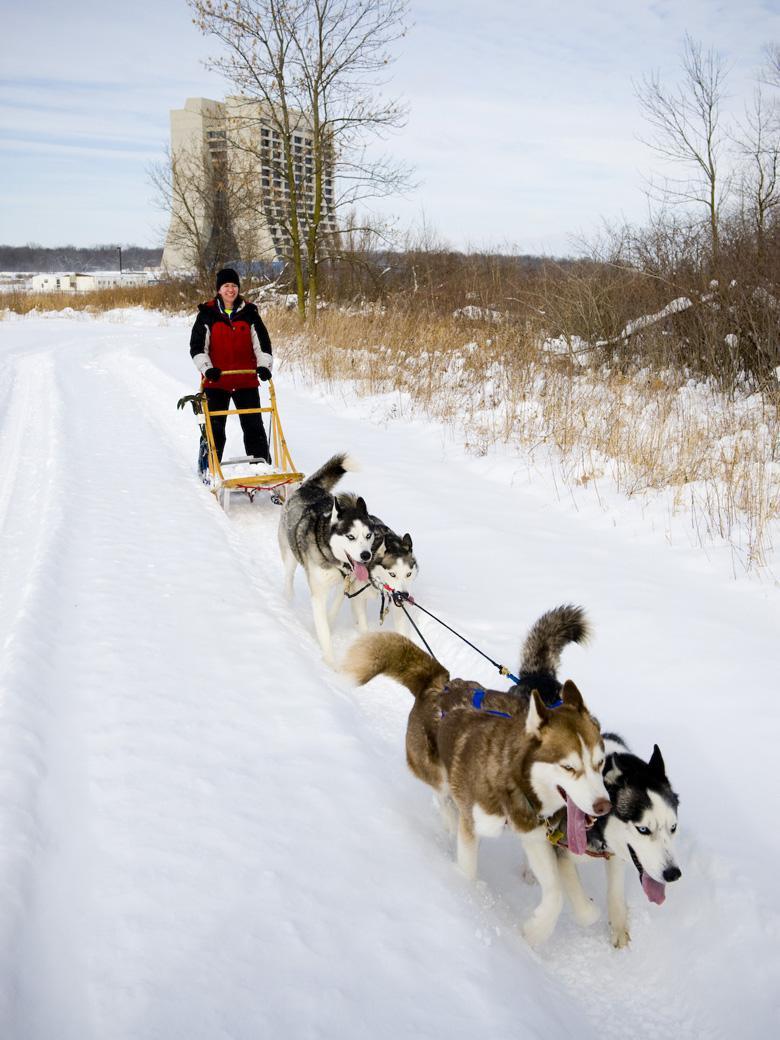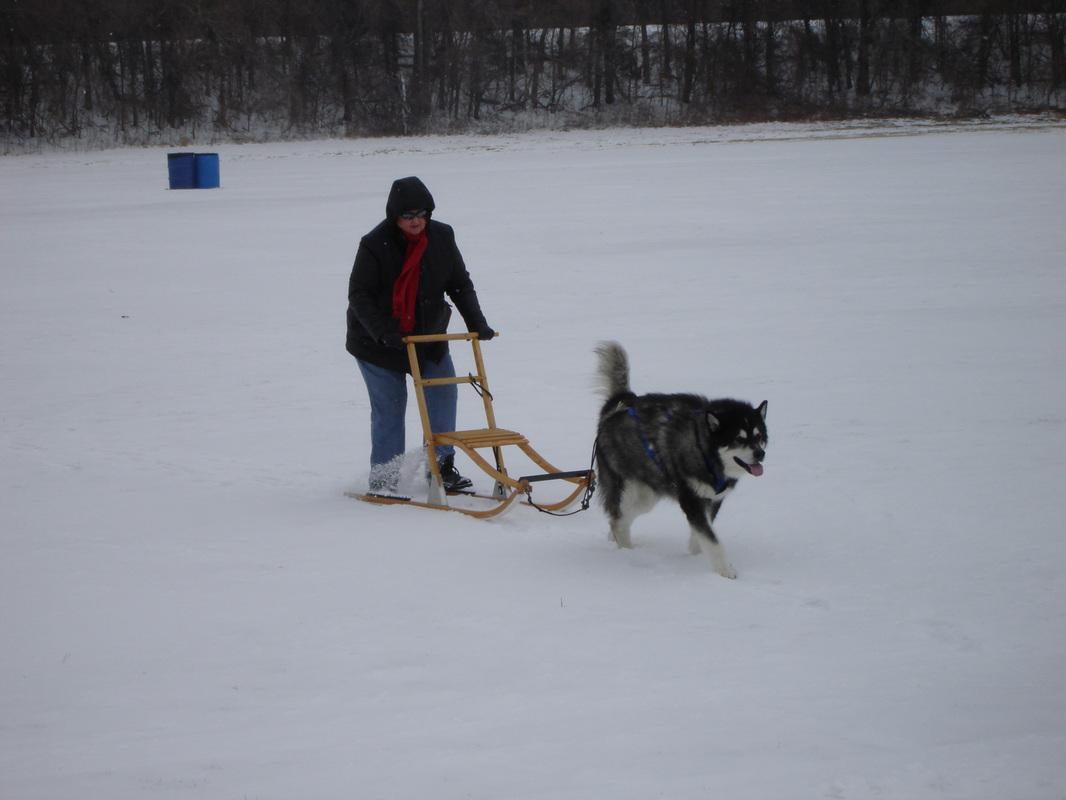The first image is the image on the left, the second image is the image on the right. Assess this claim about the two images: "The right image shows one person standing behind a small sled pulled by no more than two dogs and heading rightward.". Correct or not? Answer yes or no. Yes. The first image is the image on the left, the second image is the image on the right. Assess this claim about the two images: "There are more than four animals in harnesses.". Correct or not? Answer yes or no. Yes. 